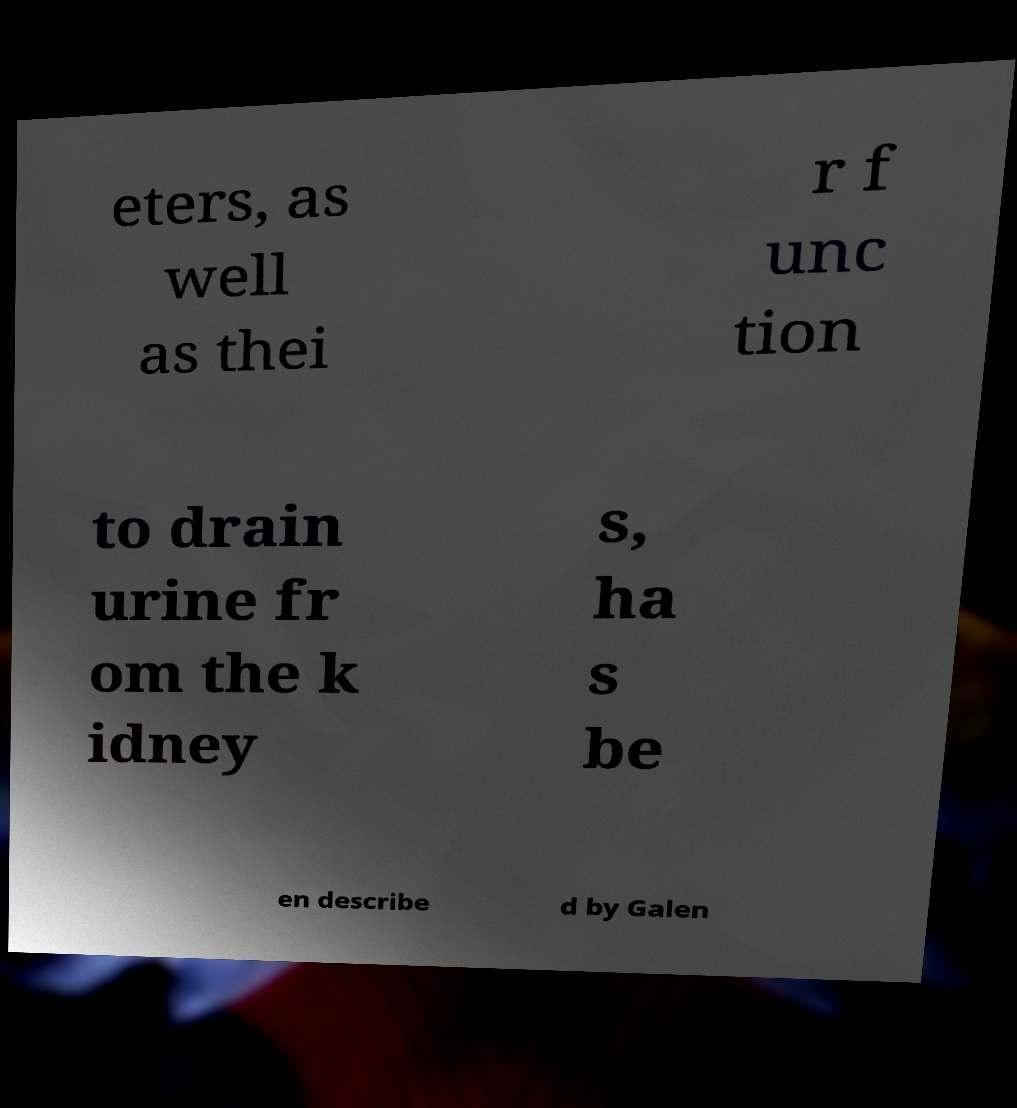Please identify and transcribe the text found in this image. eters, as well as thei r f unc tion to drain urine fr om the k idney s, ha s be en describe d by Galen 